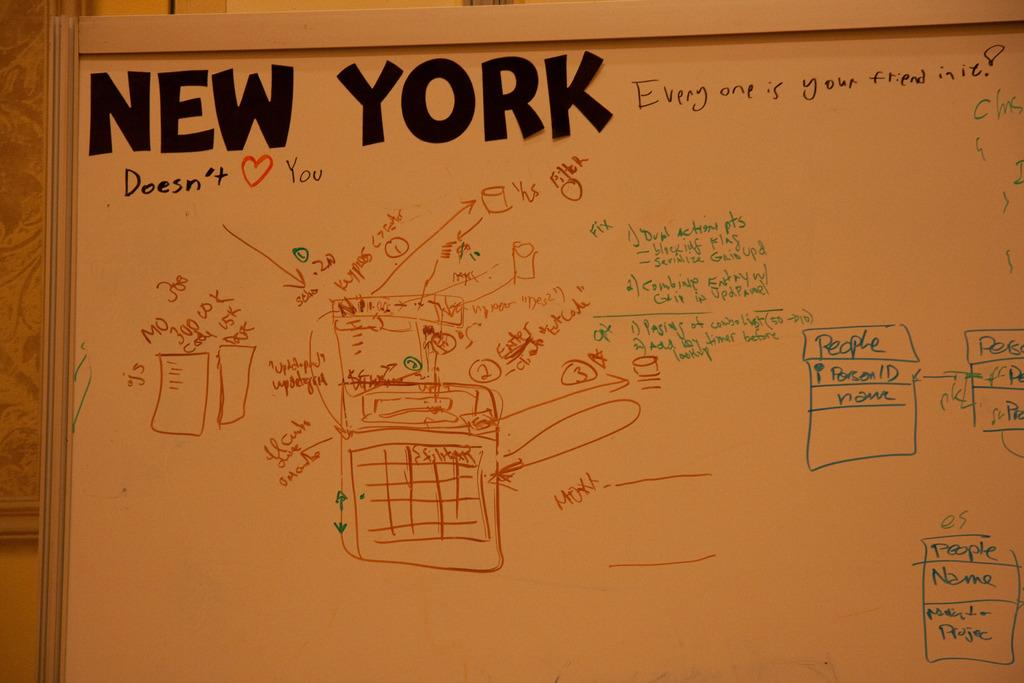What is the main object in the image? There is a board in the image. What can be seen on the board? There are diagrams and text written on the board. What type of carpenter is depicted in the act of talking on the board? There is no carpenter or act of talking present on the board; it only contains diagrams and text. 